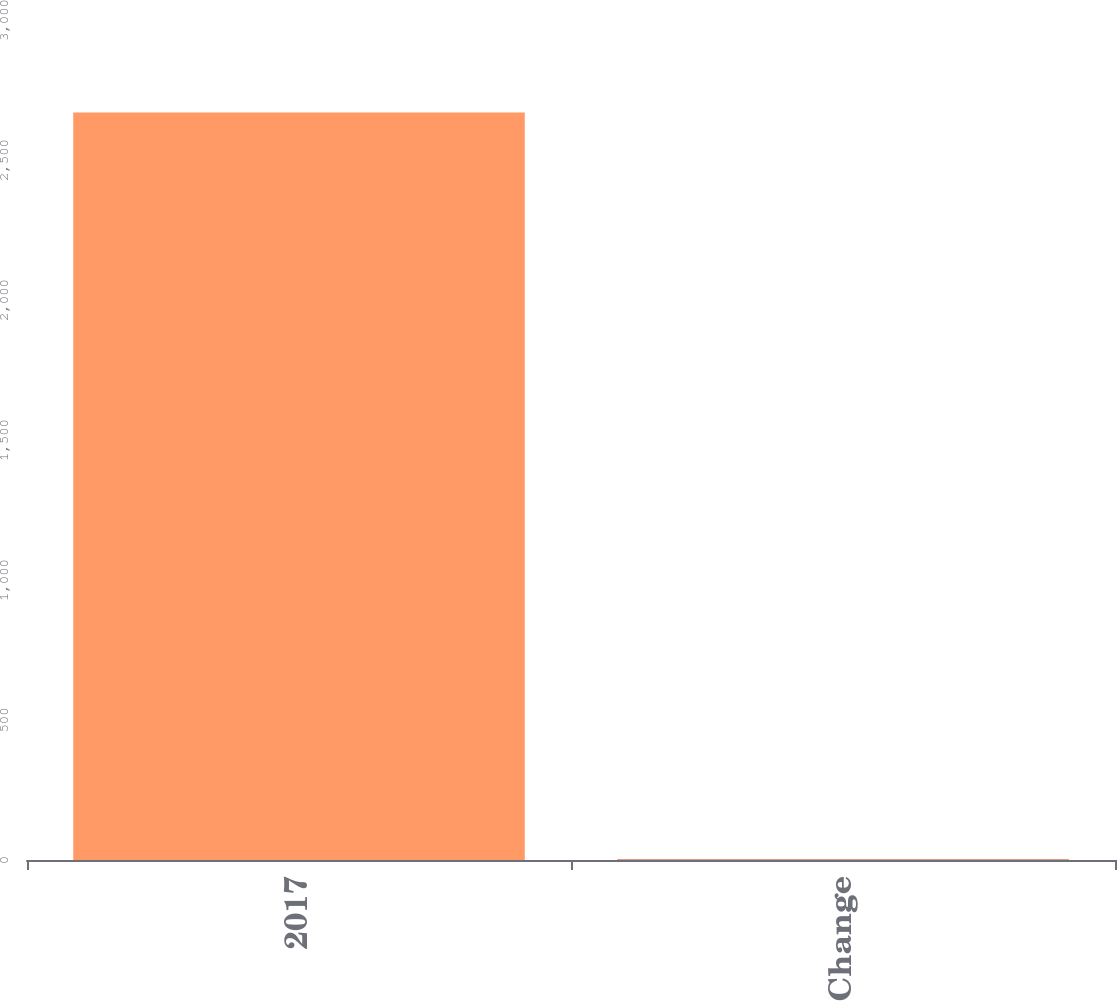Convert chart. <chart><loc_0><loc_0><loc_500><loc_500><bar_chart><fcel>2017<fcel>Change<nl><fcel>2670<fcel>2.3<nl></chart> 